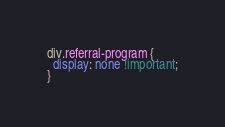Convert code to text. <code><loc_0><loc_0><loc_500><loc_500><_CSS_>div.referral-program {
  display: none !important;
}
</code> 